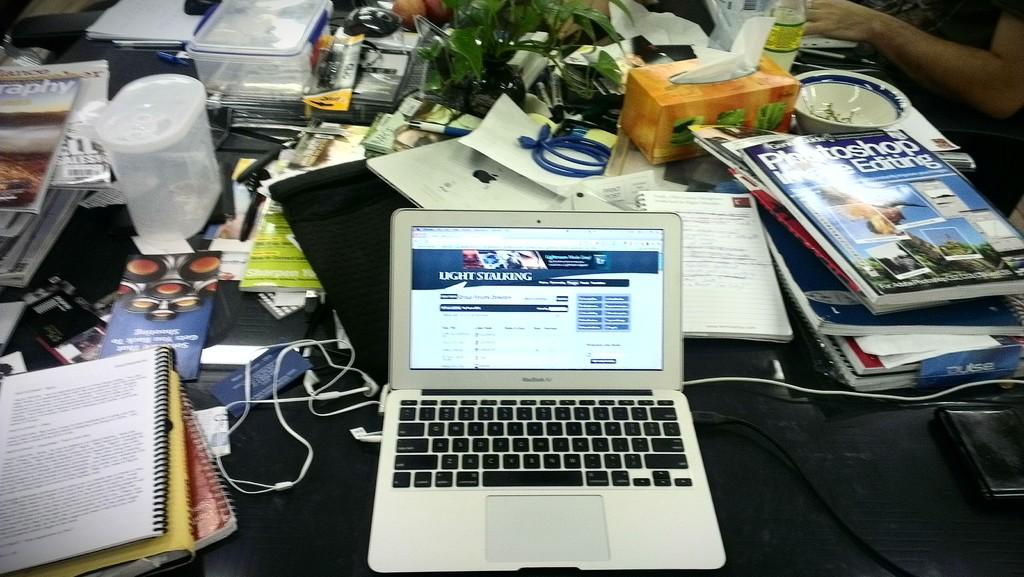<image>
Describe the image concisely. A laptop is open to a screen that says light stalking. 